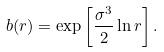Convert formula to latex. <formula><loc_0><loc_0><loc_500><loc_500>b ( r ) = \exp \left [ \frac { \sigma ^ { 3 } } { 2 } \ln r \right ] .</formula> 